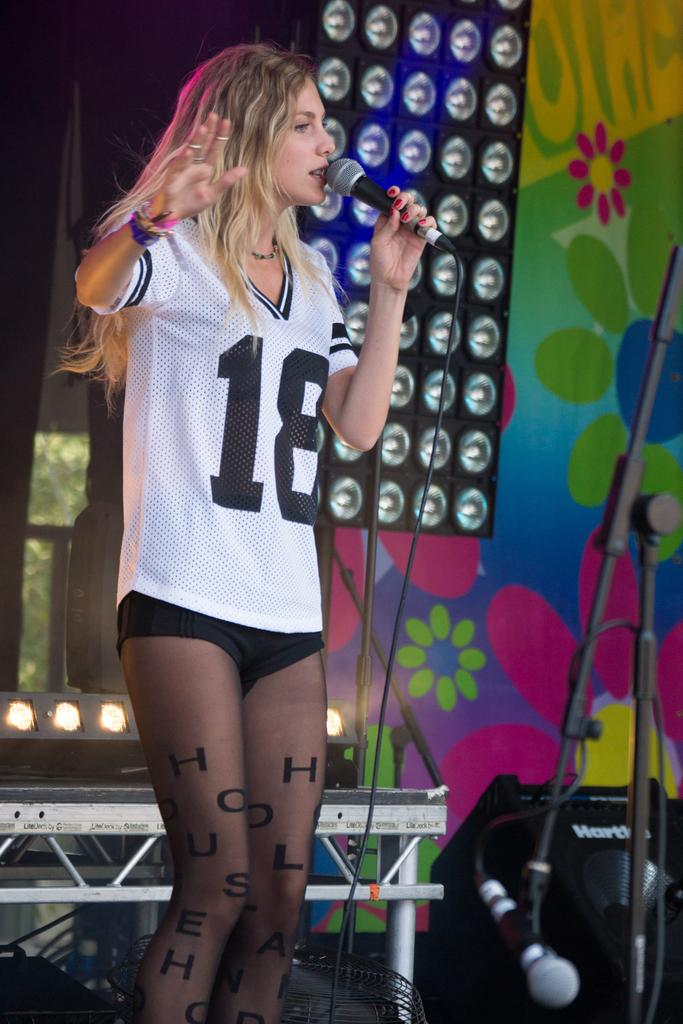<image>
Give a short and clear explanation of the subsequent image. A woman speaks into a microphone on stage while wearing a number 18 jersey. 